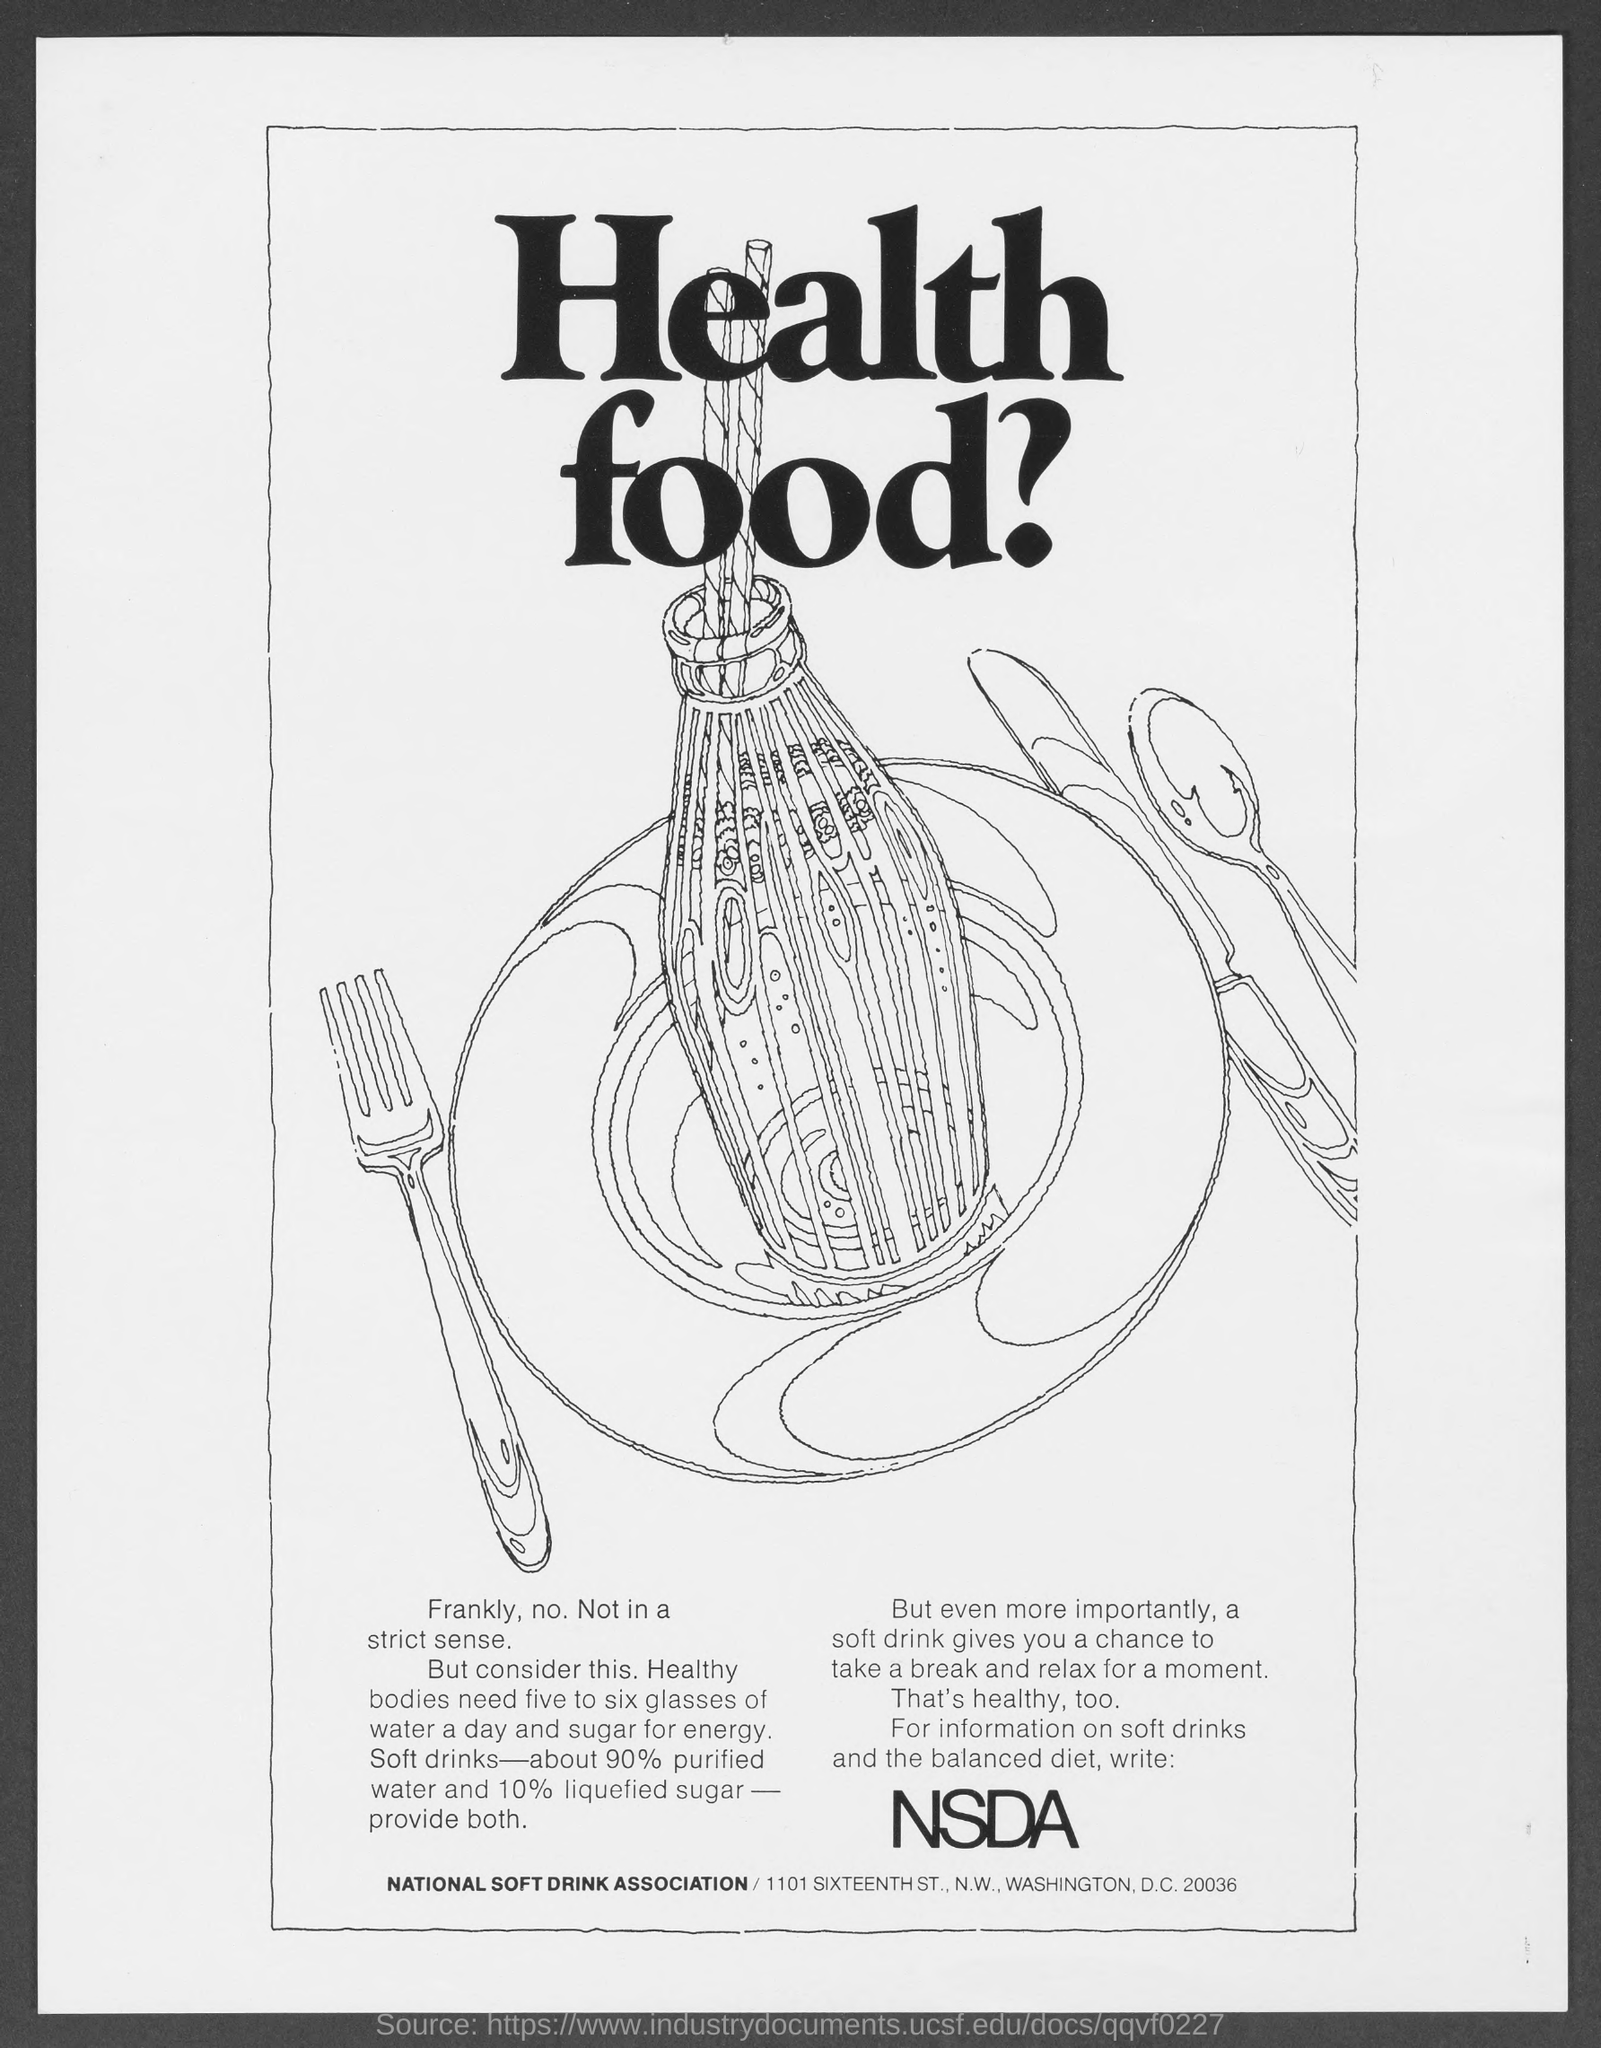Give some essential details in this illustration. Soft drinks typically contain 10% liquefied sugar. According to experts, healthy individuals require five to six glasses of water per day to maintain proper hydration. The heading of the document is "What is the heading of the Document? Health food?". According to a recent study, approximately 90% of soft drinks contain purified water. The word in large font in the text under the picture is NSDA. 